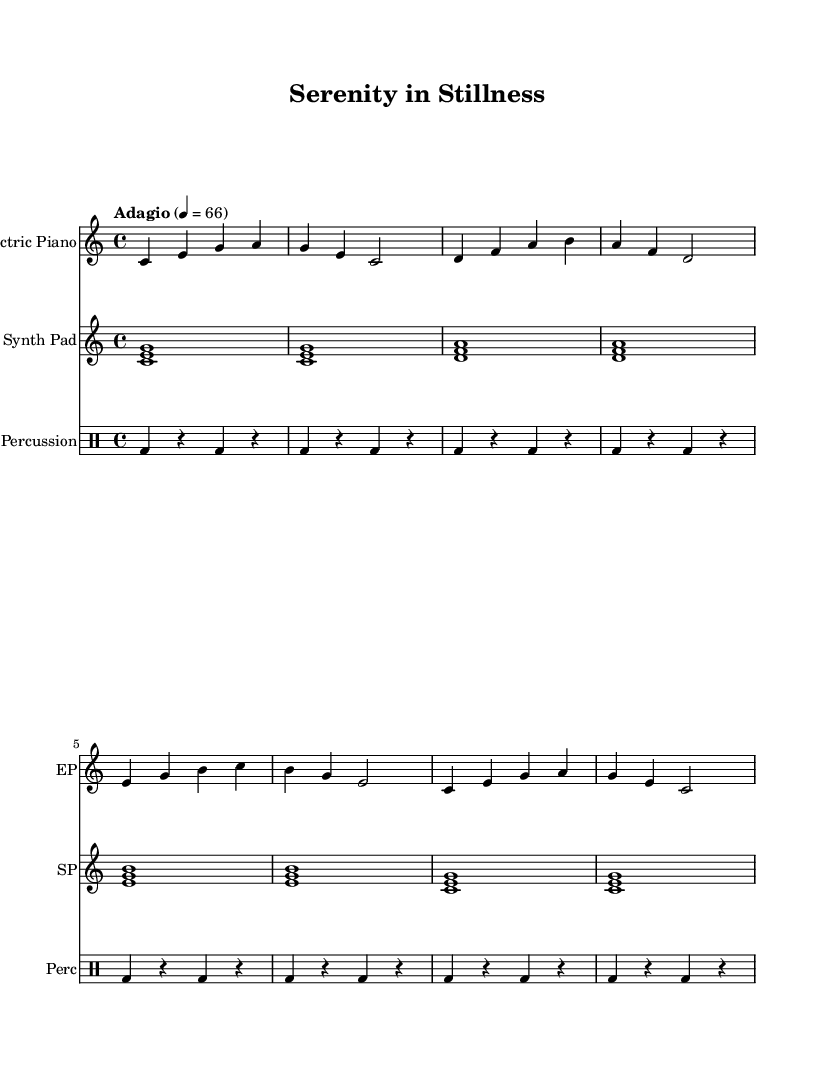What is the key signature of this music? The key signature is C major, which has no sharps or flats.
Answer: C major What is the time signature of this music? The time signature is indicated at the beginning of the sheet music, showing four beats in a measure.
Answer: 4/4 What is the tempo marking for this piece? The tempo marking is found at the beginning, indicating the speed at which the piece should be played. In this case, it is specified as Adagio, which means slowly.
Answer: Adagio How many measures are in the first system of music? By counting the distinct groups of notes and rests in the first system, one can determine how many measures are present. This piece contains eight measures in the first system.
Answer: 8 Which instrument plays a repeating chord progression? The repetition of chords can be observed in the staff designated for the synthesizer, where chords are played consistently throughout a measure. This indicates that the Synth Pad plays the repeating chord progression.
Answer: Synth Pad What kind of rhythm does the percussion section use? The percussion section can be examined for its rhythmic pattern, which includes a kick drum played on beats in a repetitive manner, showcasing a steady and simple rhythmic foundation. This implies a steady beat pattern typical of electronic music.
Answer: Steady 